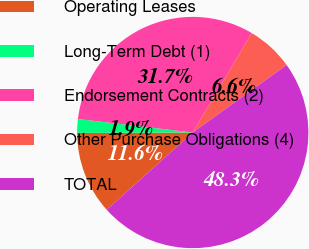Convert chart to OTSL. <chart><loc_0><loc_0><loc_500><loc_500><pie_chart><fcel>Operating Leases<fcel>Long-Term Debt (1)<fcel>Endorsement Contracts (2)<fcel>Other Purchase Obligations (4)<fcel>TOTAL<nl><fcel>11.58%<fcel>1.92%<fcel>31.65%<fcel>6.56%<fcel>48.29%<nl></chart> 